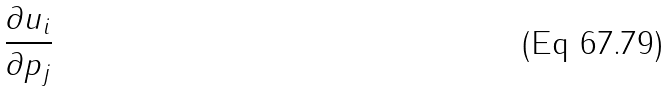<formula> <loc_0><loc_0><loc_500><loc_500>\frac { \partial u _ { i } } { \partial p _ { j } }</formula> 